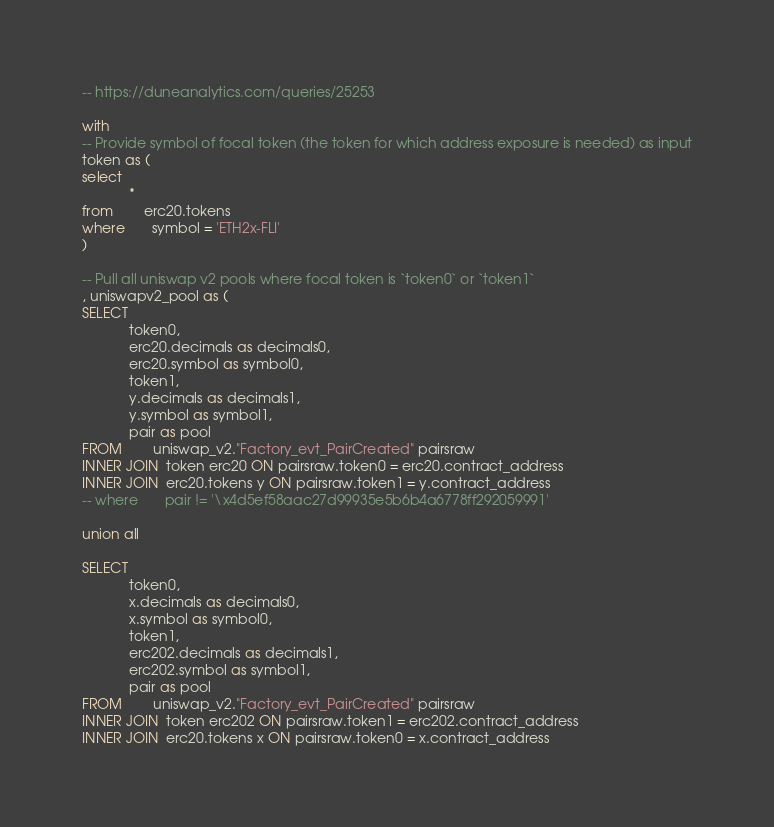Convert code to text. <code><loc_0><loc_0><loc_500><loc_500><_SQL_>-- https://duneanalytics.com/queries/25253

with 
-- Provide symbol of focal token (the token for which address exposure is needed) as input
token as (
select 
            * 
from        erc20.tokens 
where       symbol = 'ETH2x-FLI'
)

-- Pull all uniswap v2 pools where focal token is `token0` or `token1`
, uniswapv2_pool as (
SELECT
            token0,
            erc20.decimals as decimals0,
            erc20.symbol as symbol0,
            token1,
            y.decimals as decimals1,
            y.symbol as symbol1,
            pair as pool
FROM        uniswap_v2."Factory_evt_PairCreated" pairsraw
INNER JOIN  token erc20 ON pairsraw.token0 = erc20.contract_address
INNER JOIN  erc20.tokens y ON pairsraw.token1 = y.contract_address
-- where       pair != '\x4d5ef58aac27d99935e5b6b4a6778ff292059991'

union all

SELECT
            token0,
            x.decimals as decimals0,
            x.symbol as symbol0,
            token1,
            erc202.decimals as decimals1,
            erc202.symbol as symbol1,
            pair as pool
FROM        uniswap_v2."Factory_evt_PairCreated" pairsraw
INNER JOIN  token erc202 ON pairsraw.token1 = erc202.contract_address
INNER JOIN  erc20.tokens x ON pairsraw.token0 = x.contract_address</code> 